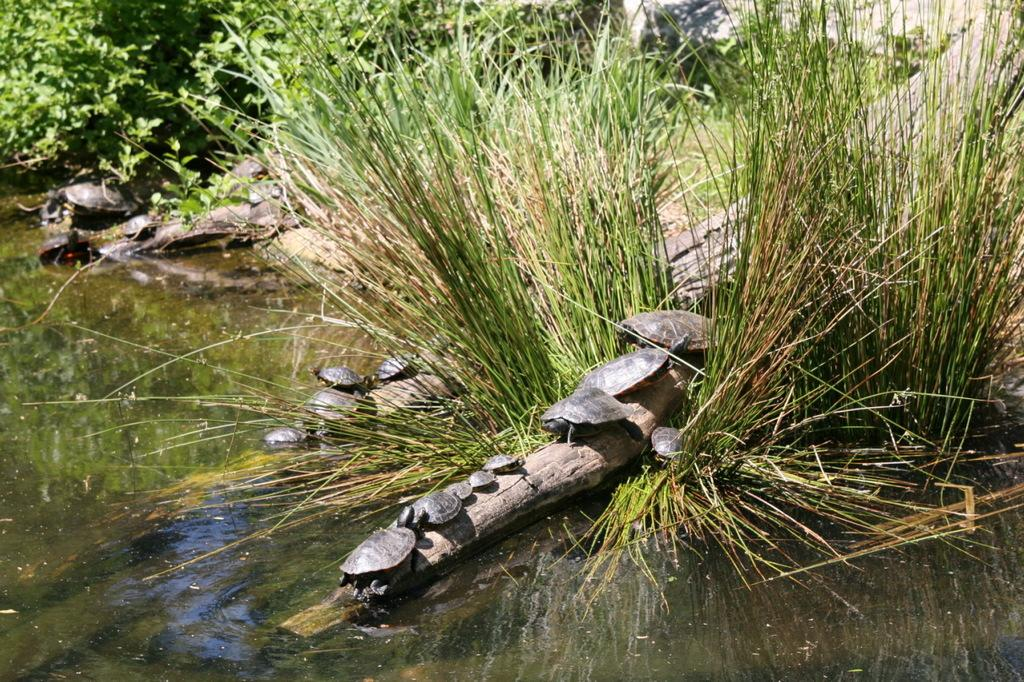Where was the picture taken? The picture was clicked outside. What can be seen in the foreground of the image? There is a water body in the foreground of the image. What animals are present in the image? There are turtles on a bamboo in the image. What type of vegetation is visible in the image? There is grass visible in the image, and there are also plants present. Can you describe any unspecified objects in the image? Unfortunately, the facts provided do not specify the nature of the unspecified objects in the image. What type of destruction can be seen in the image? There is no destruction present in the image; it features a peaceful scene with turtles on a bamboo and a water body. What kind of meeting is taking place in the image? There is no meeting depicted in the image; it shows a natural scene with turtles and a water body. 